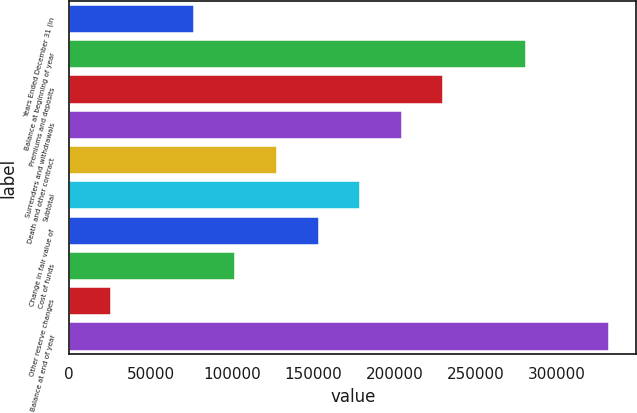Convert chart to OTSL. <chart><loc_0><loc_0><loc_500><loc_500><bar_chart><fcel>Years Ended December 31 (in<fcel>Balance at beginning of year<fcel>Premiums and deposits<fcel>Surrenders and withdrawals<fcel>Death and other contract<fcel>Subtotal<fcel>Change in fair value of<fcel>Cost of funds<fcel>Other reserve changes<fcel>Balance at end of year<nl><fcel>76648.8<fcel>281022<fcel>229928<fcel>204382<fcel>127742<fcel>178835<fcel>153289<fcel>102195<fcel>25555.6<fcel>332115<nl></chart> 